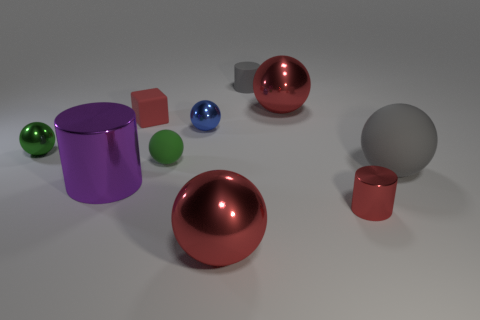What is the material of the red object that is right of the big red object on the right side of the big sphere that is in front of the tiny red cylinder?
Make the answer very short. Metal. Is the material of the purple cylinder the same as the small red object left of the tiny green matte thing?
Your response must be concise. No. Are there fewer rubber balls that are in front of the small red shiny object than red balls in front of the purple cylinder?
Your answer should be compact. Yes. How many small cylinders are made of the same material as the large cylinder?
Offer a terse response. 1. Is there a matte sphere that is left of the gray object that is behind the red thing that is left of the blue shiny sphere?
Your response must be concise. Yes. What number of blocks are green metallic objects or metal things?
Provide a short and direct response. 0. Does the green matte thing have the same shape as the blue metal thing that is on the right side of the tiny green metal object?
Offer a very short reply. Yes. Are there fewer metallic cylinders that are in front of the small red block than big purple shiny blocks?
Give a very brief answer. No. There is a big metallic cylinder; are there any tiny blue spheres in front of it?
Make the answer very short. No. Are there any large purple things that have the same shape as the tiny green metal thing?
Make the answer very short. No. 